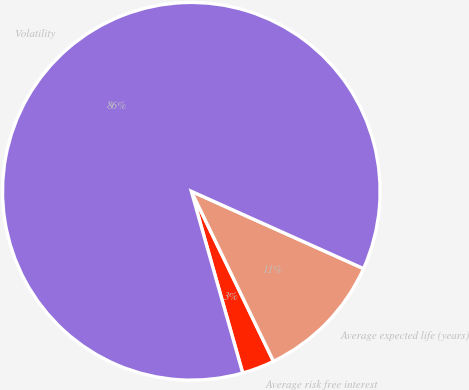<chart> <loc_0><loc_0><loc_500><loc_500><pie_chart><fcel>Average risk free interest<fcel>Average expected life (years)<fcel>Volatility<nl><fcel>2.78%<fcel>11.12%<fcel>86.1%<nl></chart> 